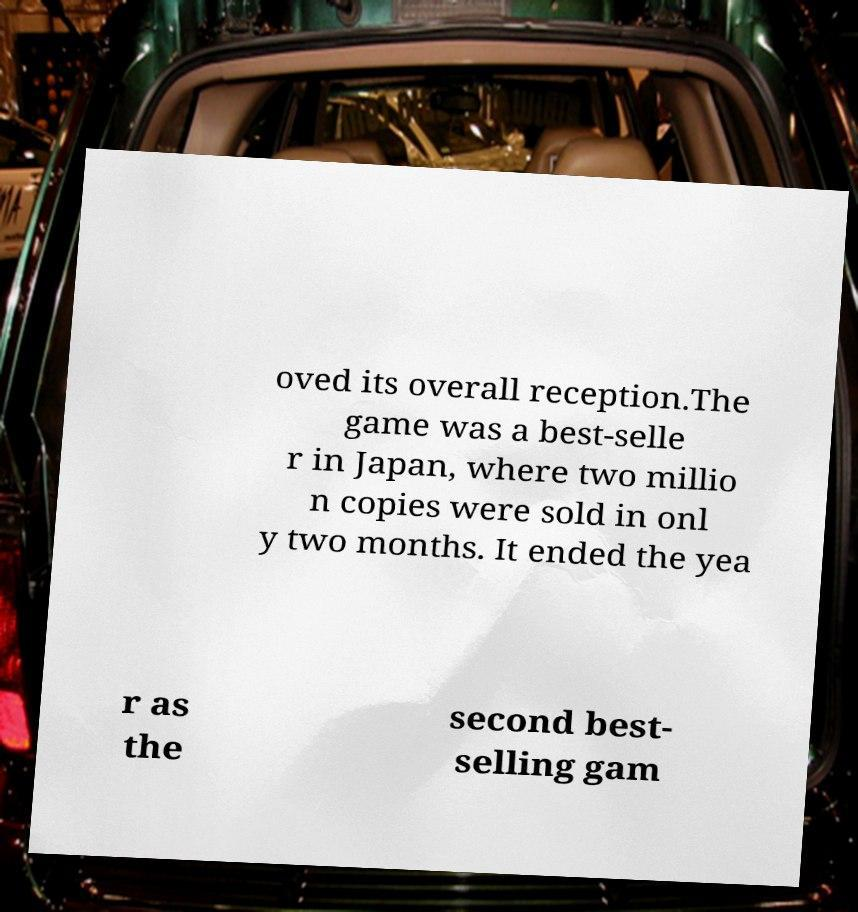I need the written content from this picture converted into text. Can you do that? oved its overall reception.The game was a best-selle r in Japan, where two millio n copies were sold in onl y two months. It ended the yea r as the second best- selling gam 